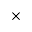Convert formula to latex. <formula><loc_0><loc_0><loc_500><loc_500>\times</formula> 